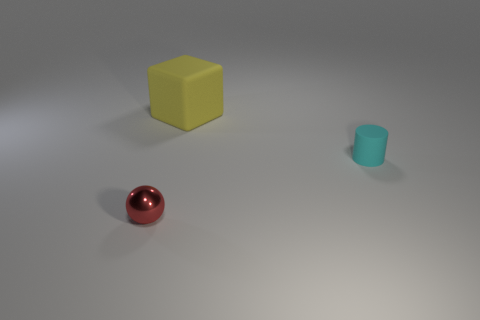Are there any other things that are the same material as the red ball?
Your answer should be very brief. No. What is the material of the tiny thing that is in front of the cyan cylinder?
Offer a very short reply. Metal. Is there a large red metal object of the same shape as the tiny cyan rubber object?
Your response must be concise. No. What number of other red shiny objects have the same shape as the metallic thing?
Give a very brief answer. 0. There is a object that is in front of the cyan rubber object; is it the same size as the matte object left of the small cylinder?
Your response must be concise. No. What is the shape of the small object that is left of the small thing that is right of the large rubber block?
Keep it short and to the point. Sphere. Are there the same number of red shiny spheres that are to the right of the ball and red objects?
Your answer should be compact. No. The small object behind the object that is in front of the tiny object behind the tiny red metal object is made of what material?
Provide a succinct answer. Rubber. Is there a object of the same size as the cylinder?
Provide a succinct answer. Yes. The small cyan thing has what shape?
Offer a very short reply. Cylinder. 